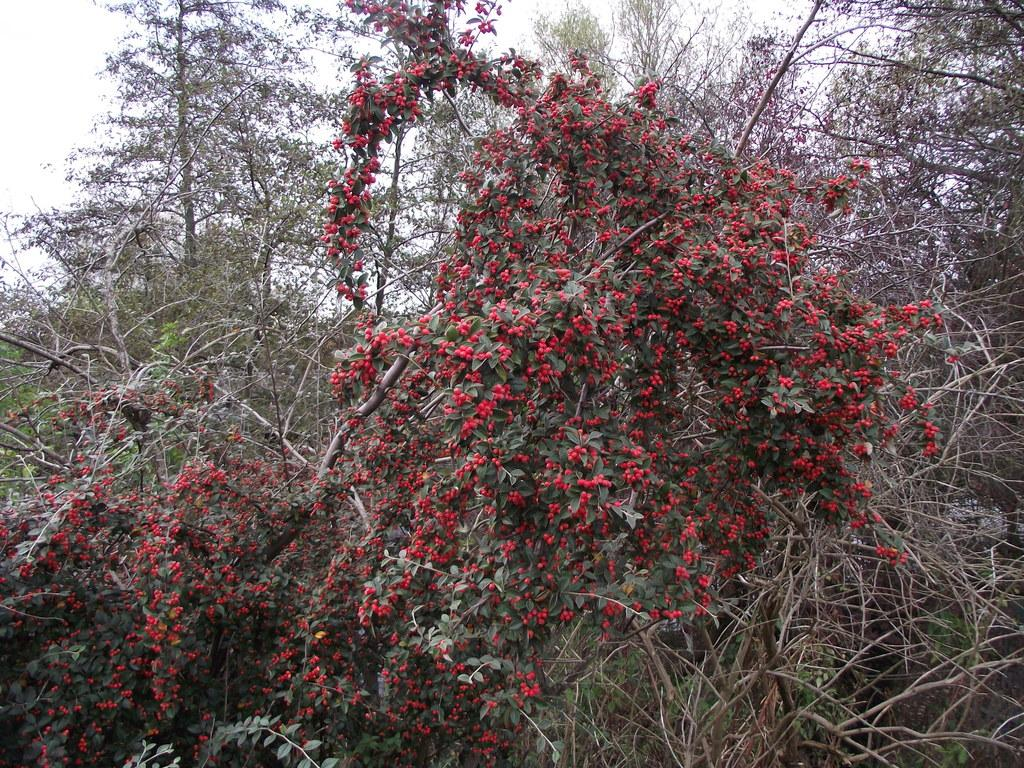What type of vegetation can be seen in the image? There are trees in the image. Are there any specific features of the trees? One of the trees has fruits. What rule is being enforced in the image regarding the quince? There is no mention of quince or any rules in the image. 